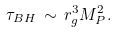<formula> <loc_0><loc_0><loc_500><loc_500>\tau _ { B H } \, \sim \, r _ { g } ^ { 3 } M _ { P } ^ { 2 } .</formula> 